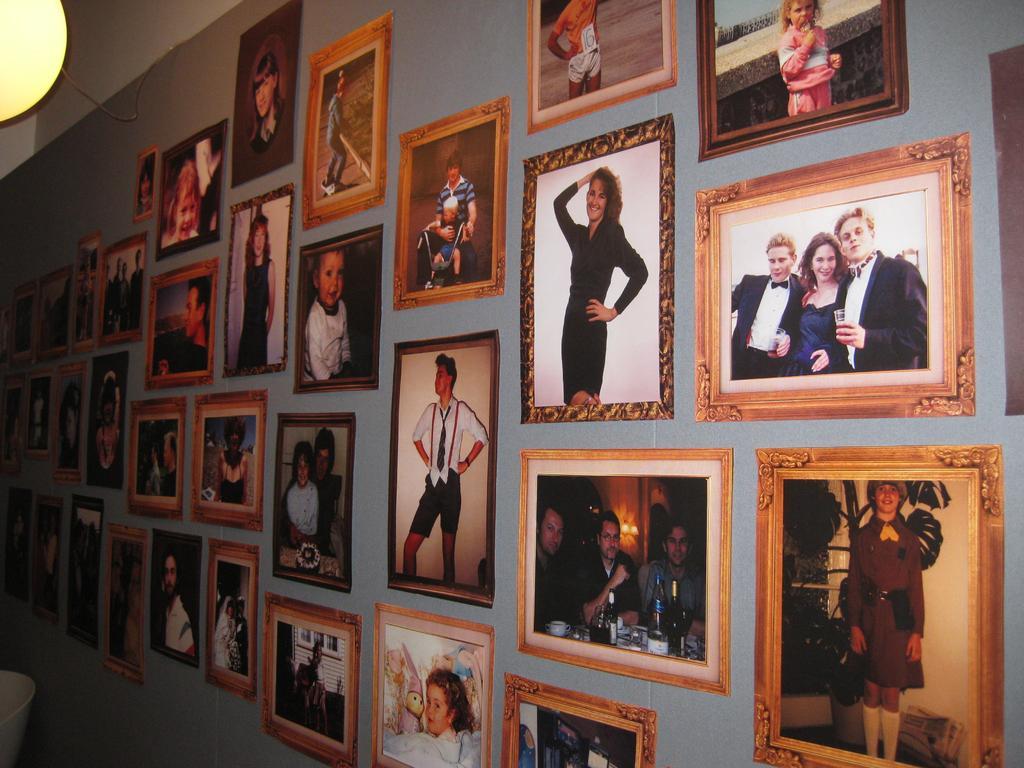In one or two sentences, can you explain what this image depicts? In the image we can see there are many frames, stick to the wall. In each frame we can see there is photos of people. This is a light and a cable wire. 